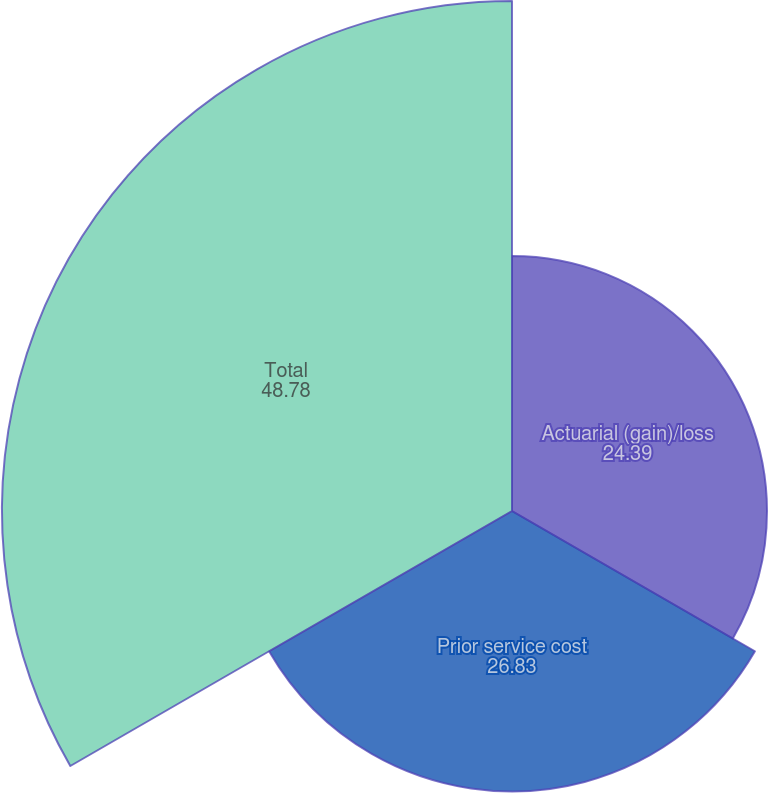Convert chart. <chart><loc_0><loc_0><loc_500><loc_500><pie_chart><fcel>Actuarial (gain)/loss<fcel>Prior service cost<fcel>Total<nl><fcel>24.39%<fcel>26.83%<fcel>48.78%<nl></chart> 